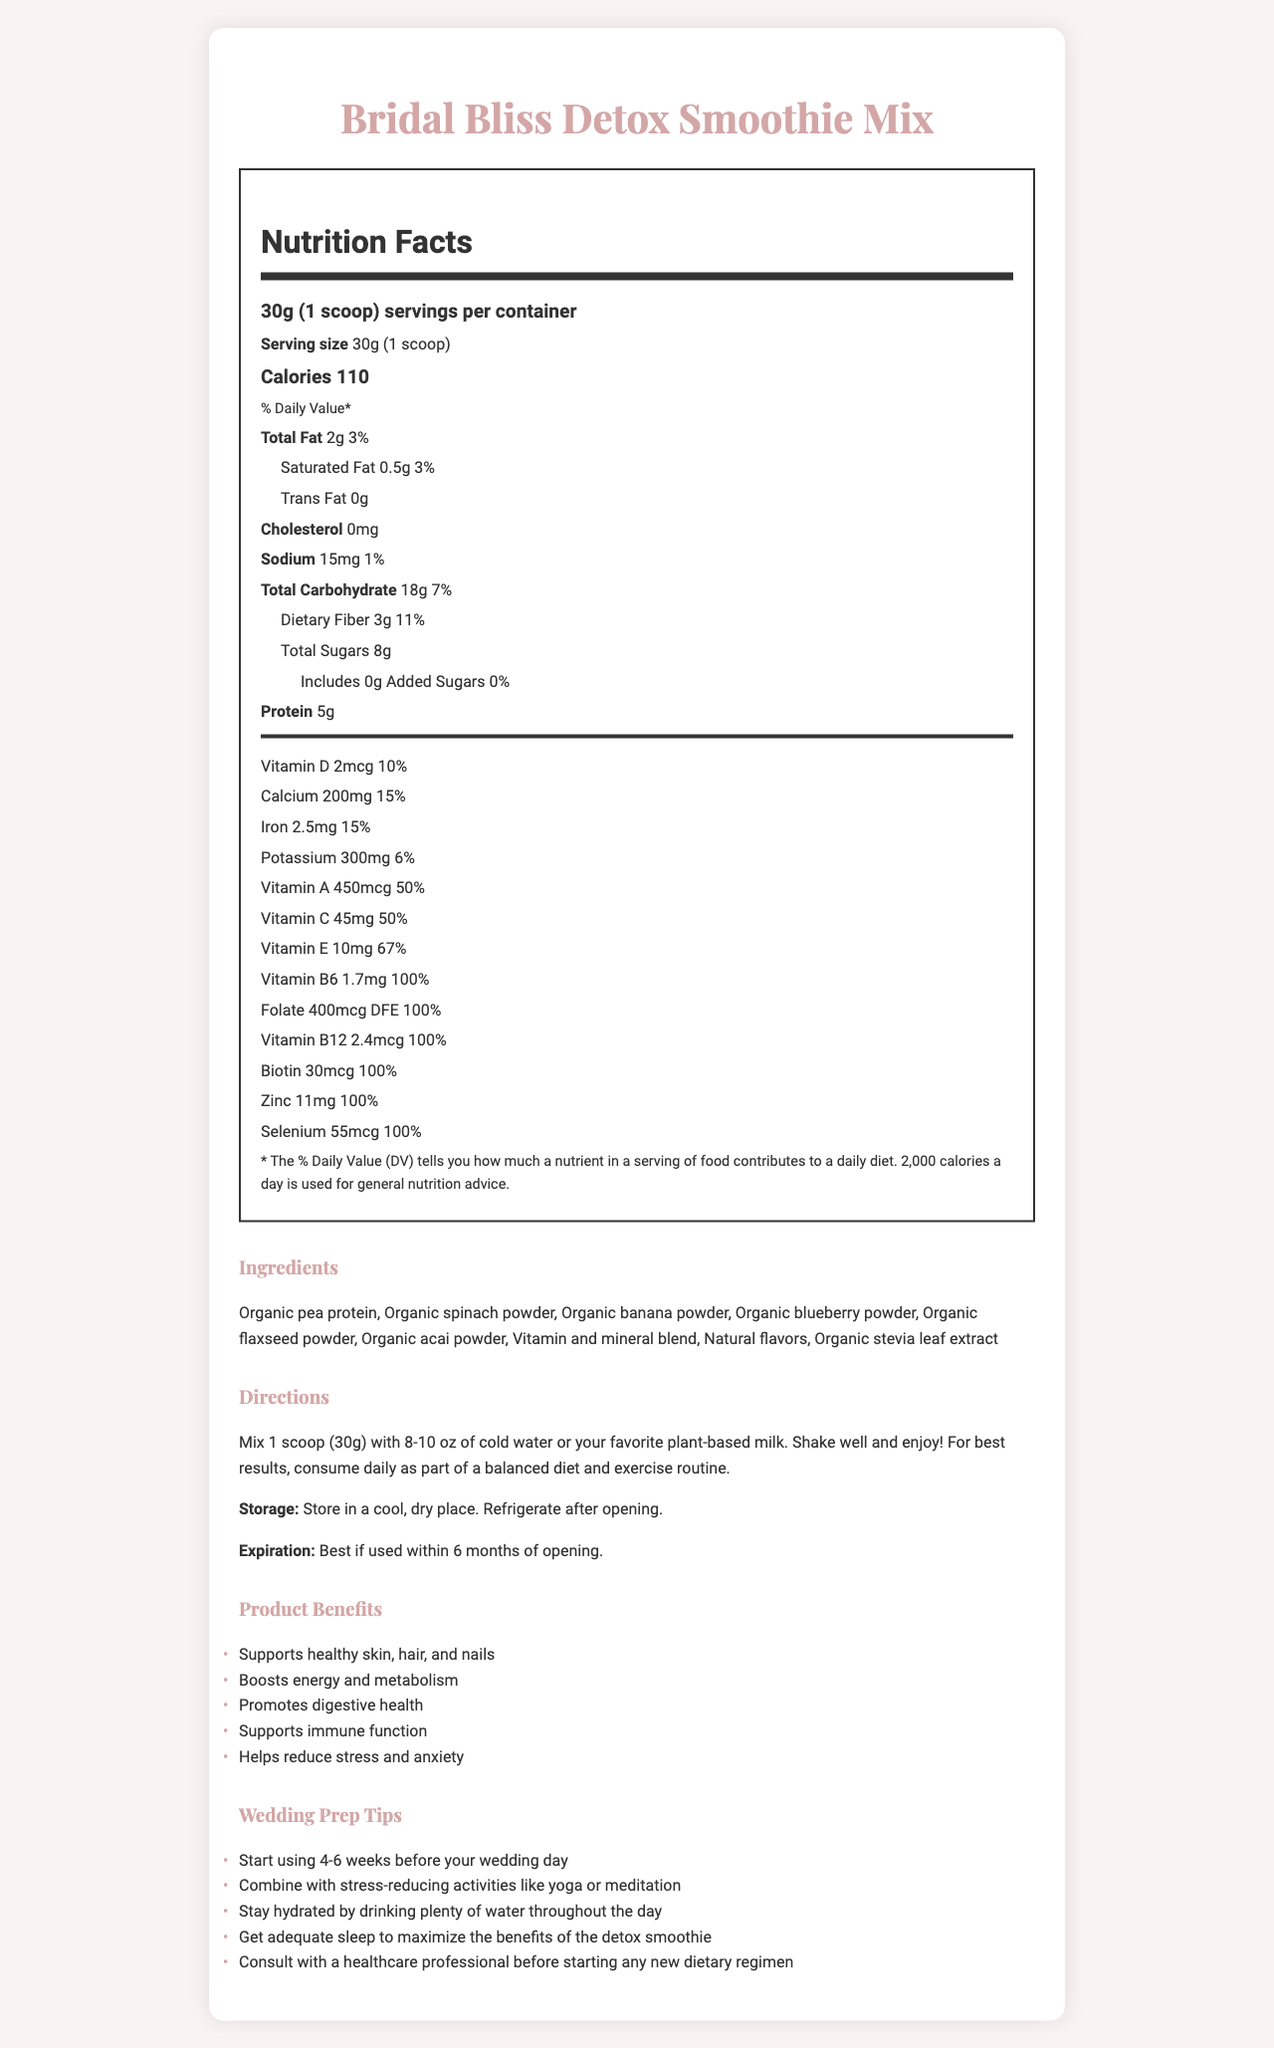What is the serving size of the Bridal Bliss Detox Smoothie Mix? The document states the serving size is 30g or 1 scoop.
Answer: 30g (1 scoop) How many servings are there per container? According to the document, there are 15 servings per container.
Answer: 15 servings Which vitamin is included in the highest daily value percentage? The document mentions that Vitamin B6 is included at 100% of the daily value.
Answer: Vitamin B6 How many grams of dietary fiber are in each serving of the Bridal Bliss Detox Smoothie Mix? The document states that there are 3 grams of dietary fiber per serving.
Answer: 3g What should you mix the smoothie mix with, according to the directions? The directions specify mixing 1 scoop with 8-10 oz of cold water or plant-based milk.
Answer: 8-10 oz of cold water or favorite plant-based milk What is the daily value percentage for zinc? The document lists the daily value percentage for zinc as 100%.
Answer: 100% Which of the following is not an ingredient in the Bridal Bliss Detox Smoothie Mix? A. Organic spinach powder B. Organic banana powder C. Organic almond powder D. Organic stevia leaf extract The listed ingredients include organic spinach powder, organic banana powder, and organic stevia leaf extract, but not organic almond powder.
Answer: C. Organic almond powder What is the main health benefit highlighted for skin, hair, and nails? A. Supports immune function B. Boosts energy and metabolism C. Supports healthy skin, hair, and nails D. Promotes digestive health The document lists supporting healthy skin, hair, and nails as one of the product benefits.
Answer: C. Supports healthy skin, hair, and nails Does the product have any cholesterol? The document states that the product has 0mg of cholesterol.
Answer: No Is this product suitable for someone with a tree nut allergy? The allergen information states that it is processed in a facility that also processes tree nuts, peanuts, and soy.
Answer: It might not be safe Please describe the main ideas covered in the document. The document includes nutritional information per serving size, ingredients, allergen information, usage directions, and benefits. It also provides tips for maximizing the product's effectiveness before the wedding.
Answer: Bridal Bliss Detox Smoothie Mix provides a detailed nutrition label, ingredient list, and directions for use. It emphasizes various vitamins and minerals, highlighting several health benefits and wedding preparation tips. How many total milligrams of calcium are in one serving? The document states that there are 200mg of calcium in one serving.
Answer: 200mg What do you need to do after opening the container? The document states that the product should be refrigerated after opening.
Answer: Refrigerate How many calories are in a serving of the smoothie mix? The document lists the calorie content per serving as 110.
Answer: 110 calories Does the document provide a gluten-free certification for the product? The document does not mention anything about gluten or a gluten-free certification.
Answer: Cannot be determined What are some benefits mentioned for consuming the Bridal Bliss Detox Smoothie Mix? List at least three. The document lists these benefits directly.
Answer: Supports healthy skin, hair, and nails; Boosts energy and metabolism; Promotes digestive health 